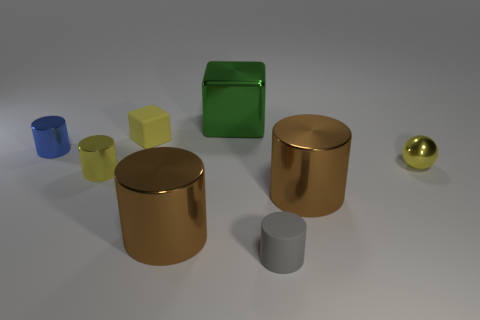Is there a gray rubber object that has the same shape as the tiny blue metal thing?
Provide a short and direct response. Yes. Is the small metal ball the same color as the tiny matte cube?
Keep it short and to the point. Yes. Is there a gray cylinder that is on the left side of the large brown metallic thing on the left side of the tiny gray matte cylinder?
Offer a very short reply. No. What number of objects are either brown cylinders on the left side of the green block or cylinders that are right of the tiny yellow rubber thing?
Provide a short and direct response. 3. What number of objects are metal objects or yellow metallic things that are right of the yellow rubber object?
Make the answer very short. 6. How big is the brown shiny cylinder on the left side of the tiny rubber object in front of the matte object behind the tiny sphere?
Provide a short and direct response. Large. There is a blue thing that is the same size as the ball; what is it made of?
Give a very brief answer. Metal. Are there any green objects of the same size as the yellow cube?
Provide a short and direct response. No. Does the cube behind the yellow rubber thing have the same size as the gray cylinder?
Offer a terse response. No. What shape is the object that is on the left side of the big metallic block and behind the small blue cylinder?
Offer a terse response. Cube. 